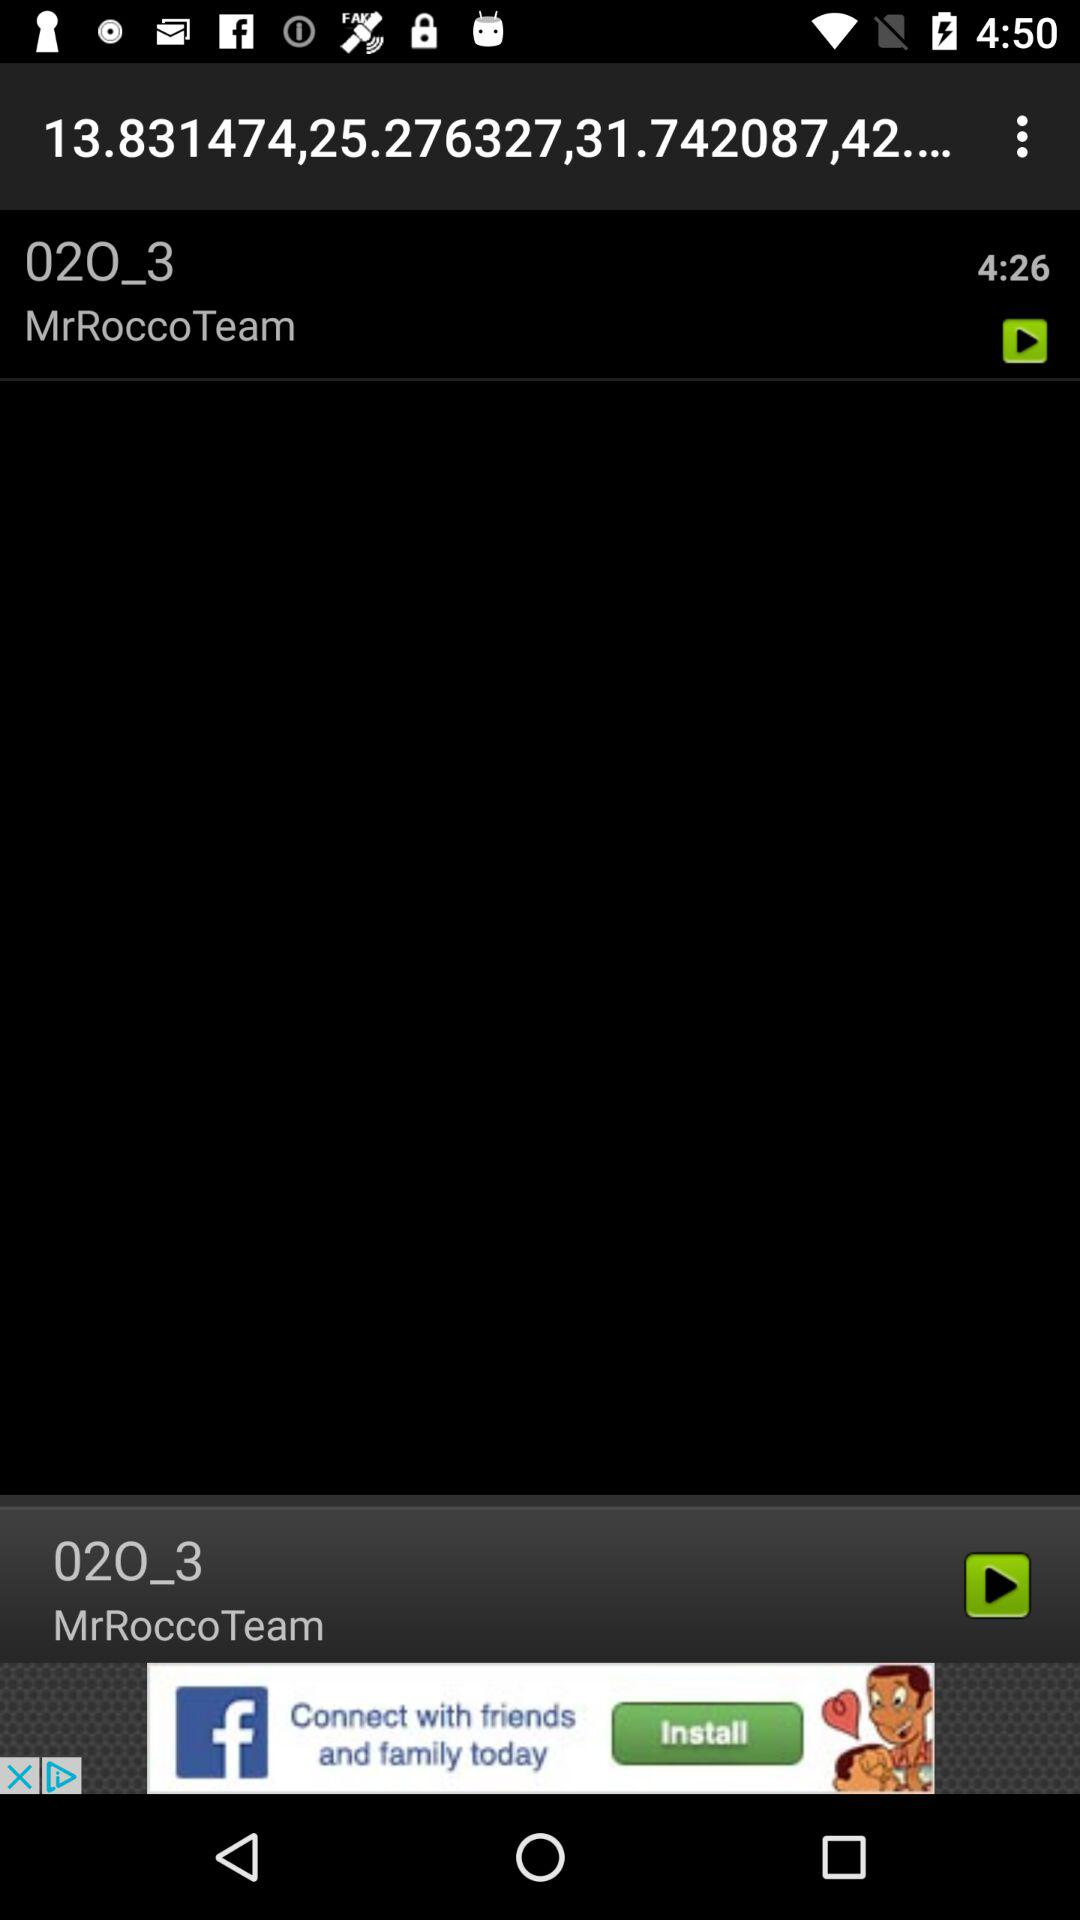What is the team name? The team name is "MrRoccoTeam". 